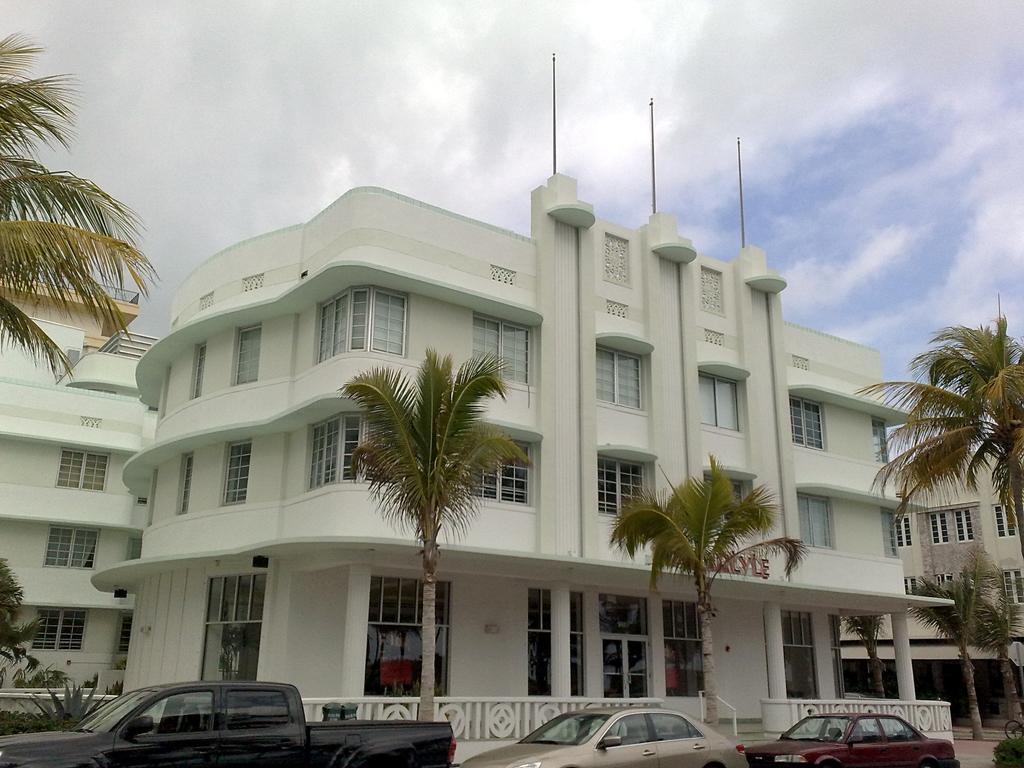Can you describe this image briefly? At the bottom, we see the cars parked on the road. Beside that, we see the trees, railing and a building in white color. On the right side, we see the trees, building, pole and a whiteboard. On the left side, we see the trees and a building in white color. At the top, we see the sky and the clouds. 